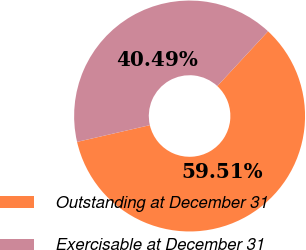Convert chart. <chart><loc_0><loc_0><loc_500><loc_500><pie_chart><fcel>Outstanding at December 31<fcel>Exercisable at December 31<nl><fcel>59.51%<fcel>40.49%<nl></chart> 